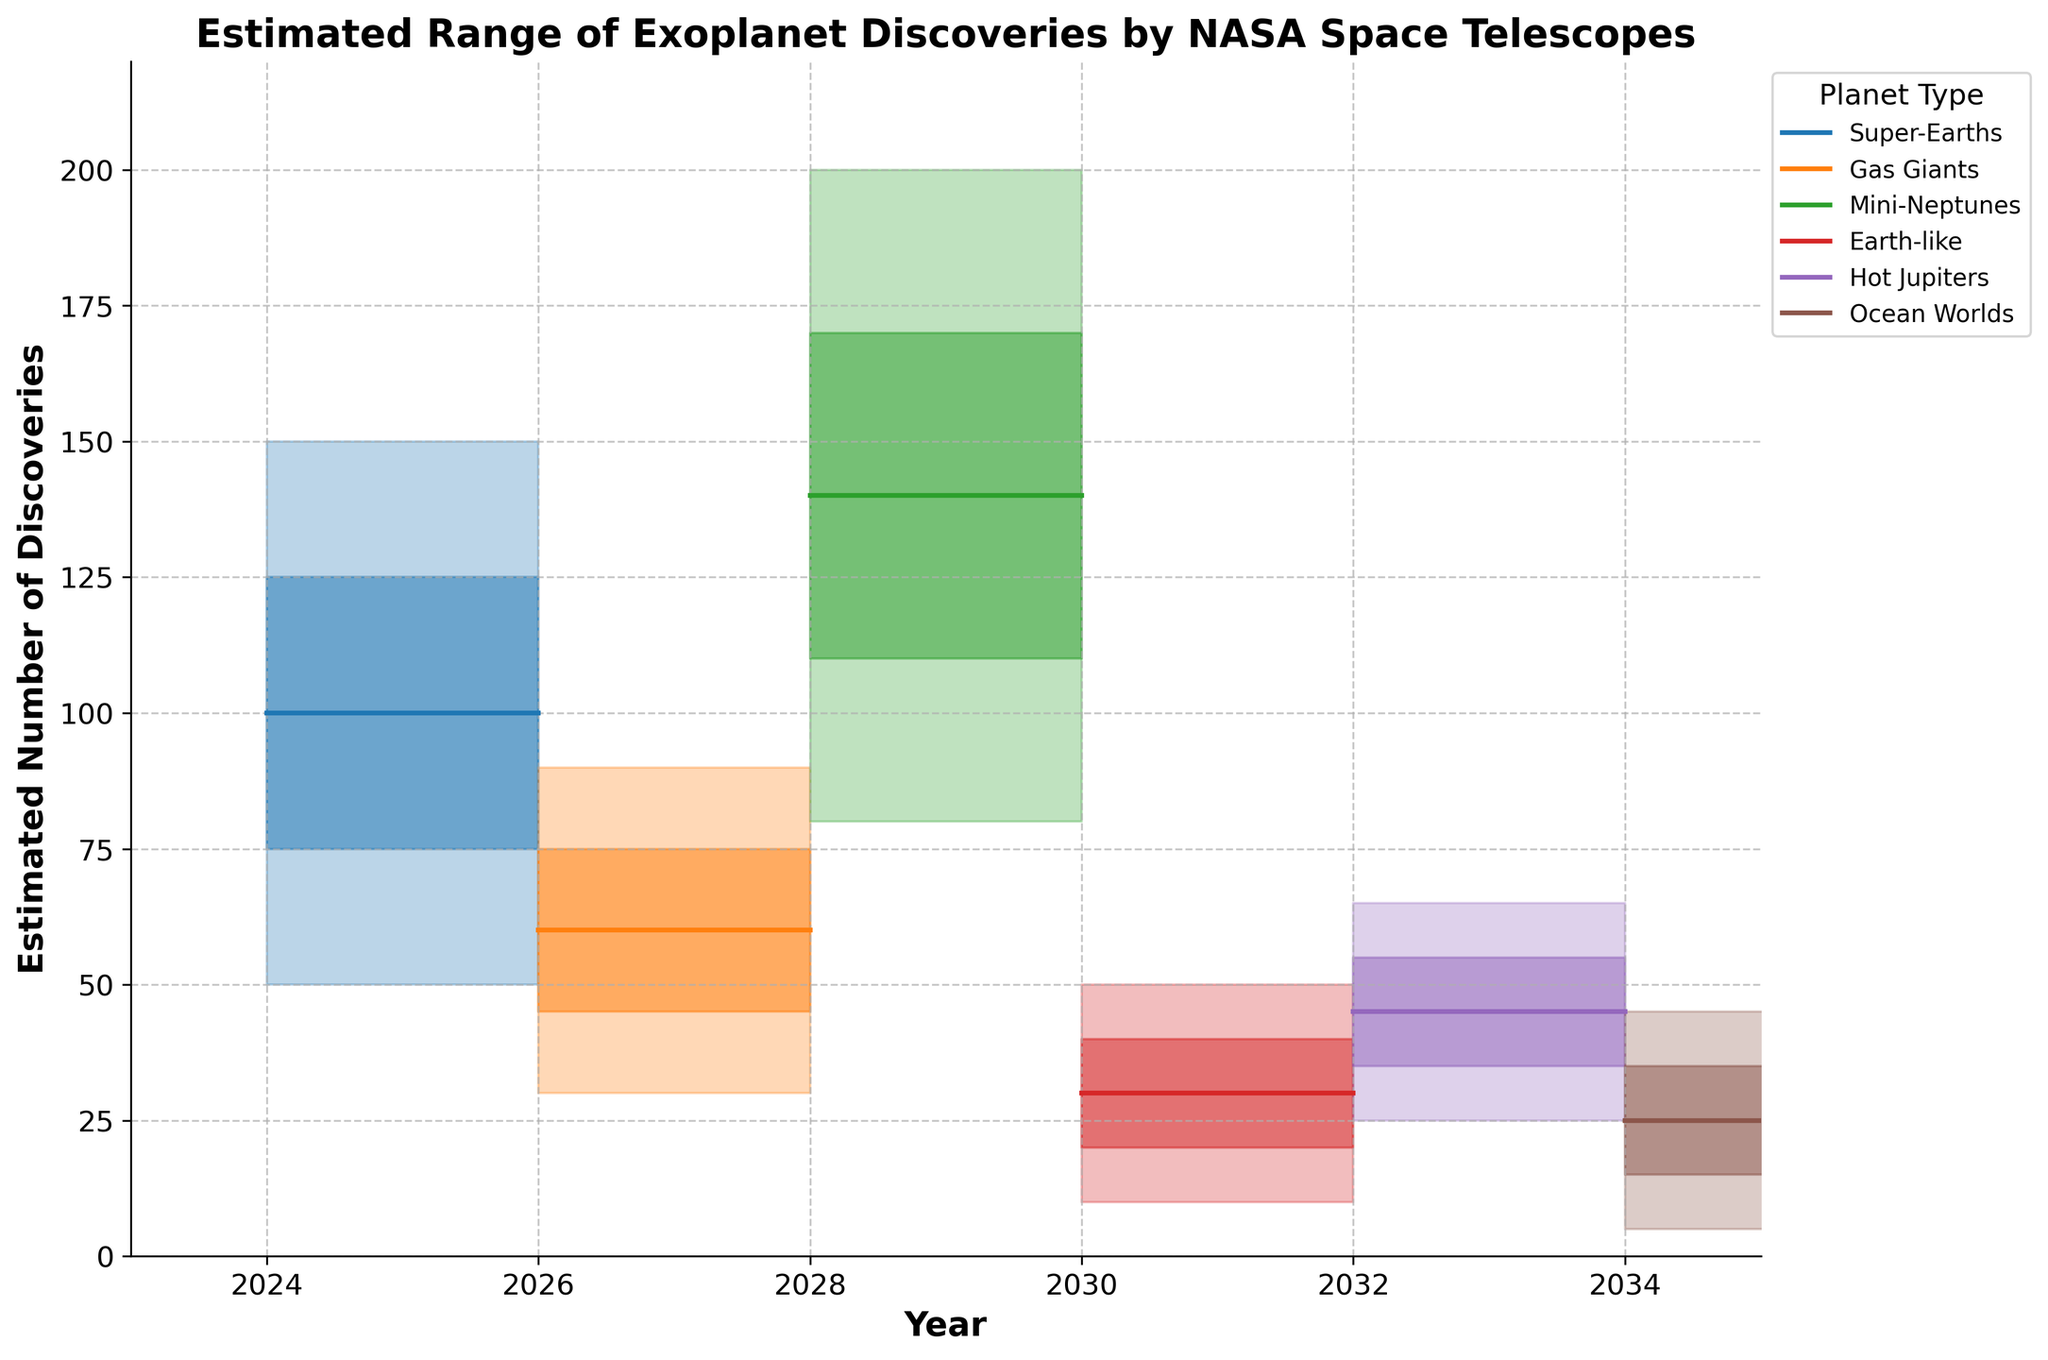What is the highest estimated number of Earth-like planets discovered in 2030? The upper estimate for Earth-like planets discovered in 2030 is 50, as shown by the top line in the shaded area for Earth-like planets in that year.
Answer: 50 Which year shows the highest middle estimate for Mini-Neptunes? In 2028, the middle estimate for Mini-Neptunes is 140, which is the highest middle estimate for this planet type across the years shown.
Answer: 2028 How does the estimated number of Gas Giants discovered in 2026 compare to Hot Jupiters in 2032? The middle estimate for Gas Giants in 2026 is 60, whereas for Hot Jupiters in 2032, it is 45. Thus, the estimate for Gas Giants is higher.
Answer: 60 is higher than 45 What is the range in the number of estimated Ocean Worlds discovered in 2034? The range is the difference between the upper and lower estimates. For Ocean Worlds in 2034, the upper estimate is 45 and the lower estimate is 5. So, the range is 45 - 5 = 40.
Answer: 40 Which planet type has the smallest range in estimates in any given year? Earth-like planets in 2030 have the smallest range in estimates. The lower estimate is 10 and the upper estimate is 50, giving a range of 40.
Answer: Earth-like in 2030 What is the average of the middle estimates for all planet types in the year 2024? The middle estimates for 2024 are: Super-Earths (100). Since Super-Earths is the only planet type with data in 2024, the average is 100.
Answer: 100 Which planet types will have an increasing middle estimate trend from 2024 to 2034? By examining the middle estimates over the years, Super-Earths, Mini-Neptunes, Earth-like, Hot Jupiters, and Ocean Worlds all show increasing trends.
Answer: Super-Earths, Mini-Neptunes, Earth-like, Hot Jupiters, Ocean Worlds What is the difference between the upper middle estimates for Super-Earths in 2024 and Mini-Neptunes in 2028? The upper middle estimate for Super-Earths in 2024 is 125, and for Mini-Neptunes in 2028 it is 170. The difference is 170 - 125 = 45.
Answer: 45 In which year will the estimated number of discoveries of Gas Giants reach or exceed 75 at any estimate level? The upper estimate for Gas Giants in 2026 is 90. This is the only occurrence where it reaches or exceeds 75.
Answer: 2026 Which planet type has the mid-range (middle estimate) closest to 60 in its respective year of discovery, and in which year does it occur? By examining the middle estimates from the data, Gas Giants in 2026 have a middle estimate of 60, closely matching the value.
Answer: Gas Giants in 2026 